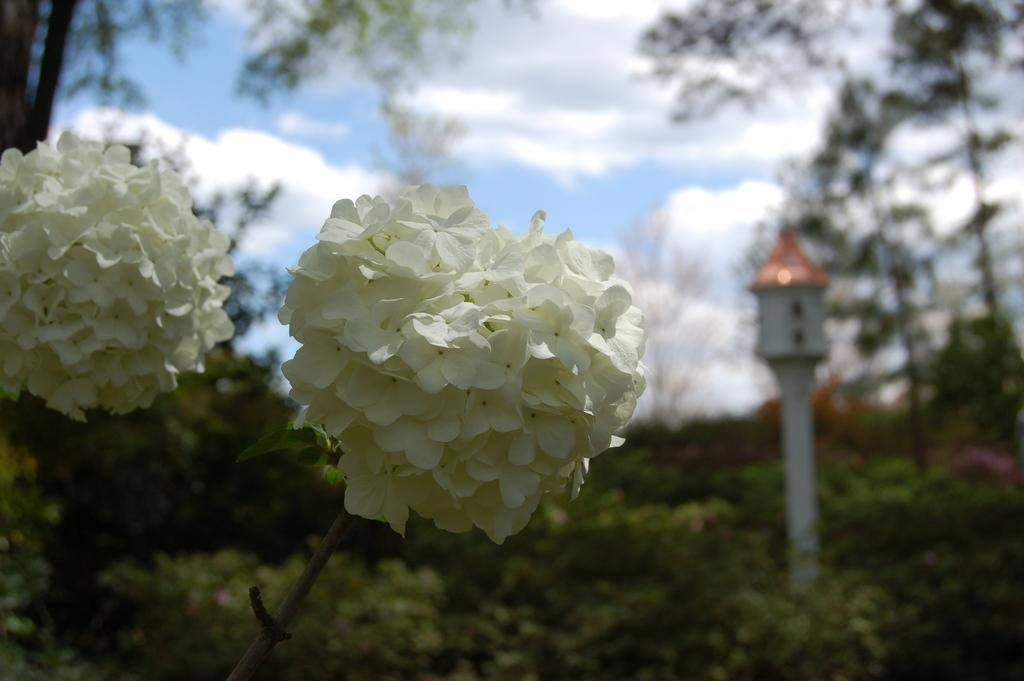What type of flora is present in the image? There are flowers in the image. What color are the flowers? The flowers are white in color. What other natural elements can be seen in the image? There are trees in the image. What man-made object is present in the image? There is a pole in the image. How would you describe the weather in the image? The sky is cloudy in the image, suggesting overcast or potentially rainy weather. How is the background of the image depicted? The background of the image is slightly blurred. Can you see any fangs or signs of anger in the image? There are no fangs or signs of anger present in the image, as it features flowers, trees, a pole, and a cloudy sky. 